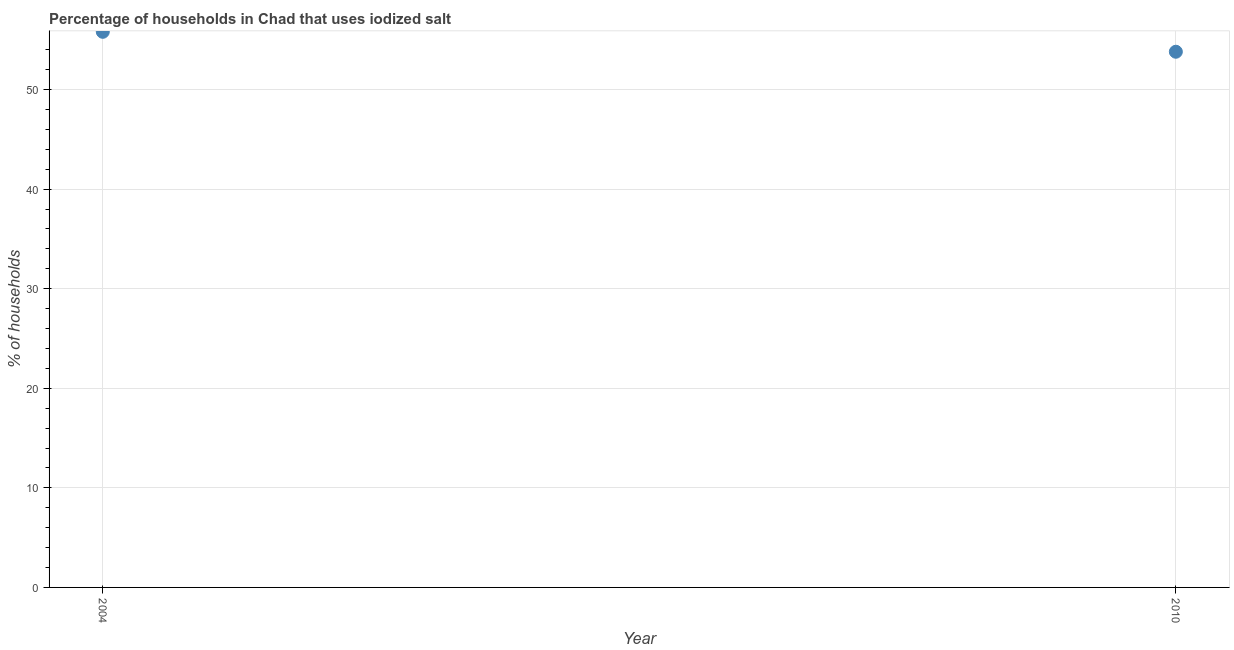What is the percentage of households where iodized salt is consumed in 2010?
Offer a terse response. 53.8. Across all years, what is the maximum percentage of households where iodized salt is consumed?
Ensure brevity in your answer.  55.8. Across all years, what is the minimum percentage of households where iodized salt is consumed?
Offer a very short reply. 53.8. In which year was the percentage of households where iodized salt is consumed maximum?
Give a very brief answer. 2004. What is the sum of the percentage of households where iodized salt is consumed?
Your answer should be very brief. 109.6. What is the difference between the percentage of households where iodized salt is consumed in 2004 and 2010?
Provide a succinct answer. 2. What is the average percentage of households where iodized salt is consumed per year?
Your answer should be very brief. 54.8. What is the median percentage of households where iodized salt is consumed?
Make the answer very short. 54.8. What is the ratio of the percentage of households where iodized salt is consumed in 2004 to that in 2010?
Keep it short and to the point. 1.04. In how many years, is the percentage of households where iodized salt is consumed greater than the average percentage of households where iodized salt is consumed taken over all years?
Your answer should be very brief. 1. Does the percentage of households where iodized salt is consumed monotonically increase over the years?
Make the answer very short. No. How many years are there in the graph?
Ensure brevity in your answer.  2. What is the difference between two consecutive major ticks on the Y-axis?
Provide a short and direct response. 10. Are the values on the major ticks of Y-axis written in scientific E-notation?
Ensure brevity in your answer.  No. Does the graph contain grids?
Offer a terse response. Yes. What is the title of the graph?
Provide a short and direct response. Percentage of households in Chad that uses iodized salt. What is the label or title of the X-axis?
Provide a succinct answer. Year. What is the label or title of the Y-axis?
Offer a very short reply. % of households. What is the % of households in 2004?
Ensure brevity in your answer.  55.8. What is the % of households in 2010?
Make the answer very short. 53.8. What is the difference between the % of households in 2004 and 2010?
Ensure brevity in your answer.  2. What is the ratio of the % of households in 2004 to that in 2010?
Your answer should be compact. 1.04. 